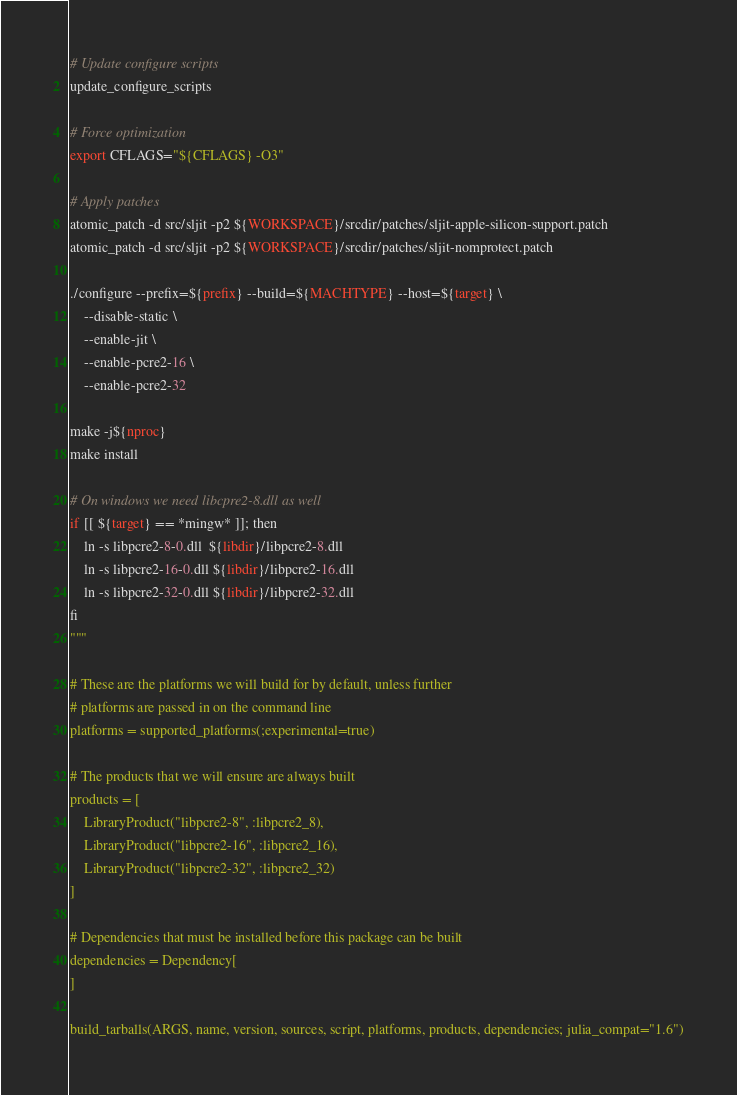<code> <loc_0><loc_0><loc_500><loc_500><_Julia_># Update configure scripts
update_configure_scripts

# Force optimization
export CFLAGS="${CFLAGS} -O3"

# Apply patches
atomic_patch -d src/sljit -p2 ${WORKSPACE}/srcdir/patches/sljit-apple-silicon-support.patch
atomic_patch -d src/sljit -p2 ${WORKSPACE}/srcdir/patches/sljit-nomprotect.patch

./configure --prefix=${prefix} --build=${MACHTYPE} --host=${target} \
    --disable-static \
    --enable-jit \
    --enable-pcre2-16 \
    --enable-pcre2-32

make -j${nproc}
make install

# On windows we need libcpre2-8.dll as well
if [[ ${target} == *mingw* ]]; then
    ln -s libpcre2-8-0.dll  ${libdir}/libpcre2-8.dll
    ln -s libpcre2-16-0.dll ${libdir}/libpcre2-16.dll
    ln -s libpcre2-32-0.dll ${libdir}/libpcre2-32.dll
fi
"""

# These are the platforms we will build for by default, unless further
# platforms are passed in on the command line
platforms = supported_platforms(;experimental=true)

# The products that we will ensure are always built
products = [
    LibraryProduct("libpcre2-8", :libpcre2_8),
    LibraryProduct("libpcre2-16", :libpcre2_16),
    LibraryProduct("libpcre2-32", :libpcre2_32)
]

# Dependencies that must be installed before this package can be built
dependencies = Dependency[
]

build_tarballs(ARGS, name, version, sources, script, platforms, products, dependencies; julia_compat="1.6")
</code> 